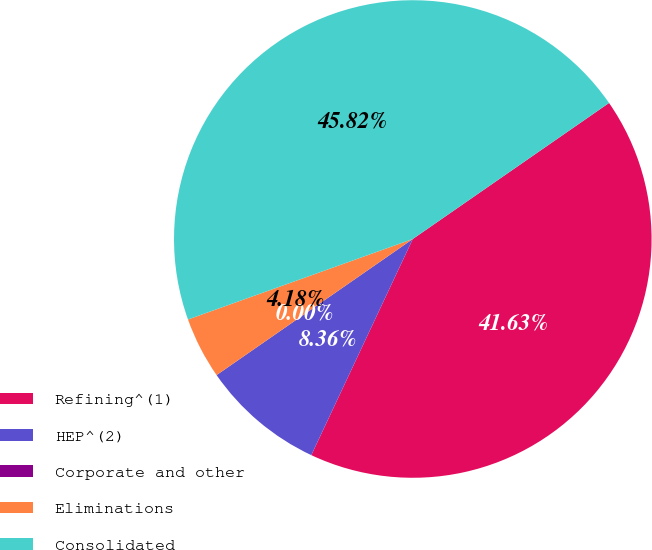<chart> <loc_0><loc_0><loc_500><loc_500><pie_chart><fcel>Refining^(1)<fcel>HEP^(2)<fcel>Corporate and other<fcel>Eliminations<fcel>Consolidated<nl><fcel>41.63%<fcel>8.36%<fcel>0.0%<fcel>4.18%<fcel>45.82%<nl></chart> 